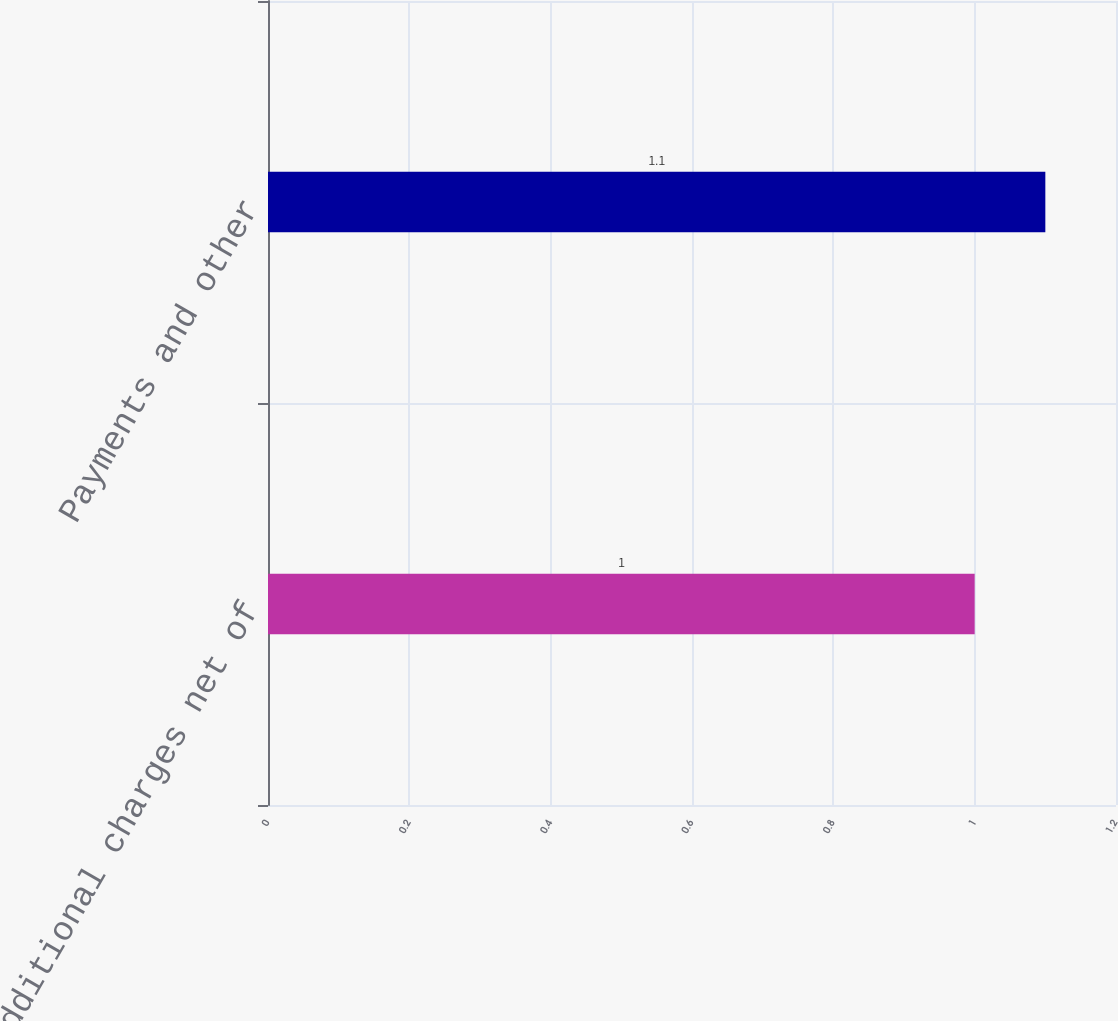Convert chart to OTSL. <chart><loc_0><loc_0><loc_500><loc_500><bar_chart><fcel>Additional charges net of<fcel>Payments and other<nl><fcel>1<fcel>1.1<nl></chart> 